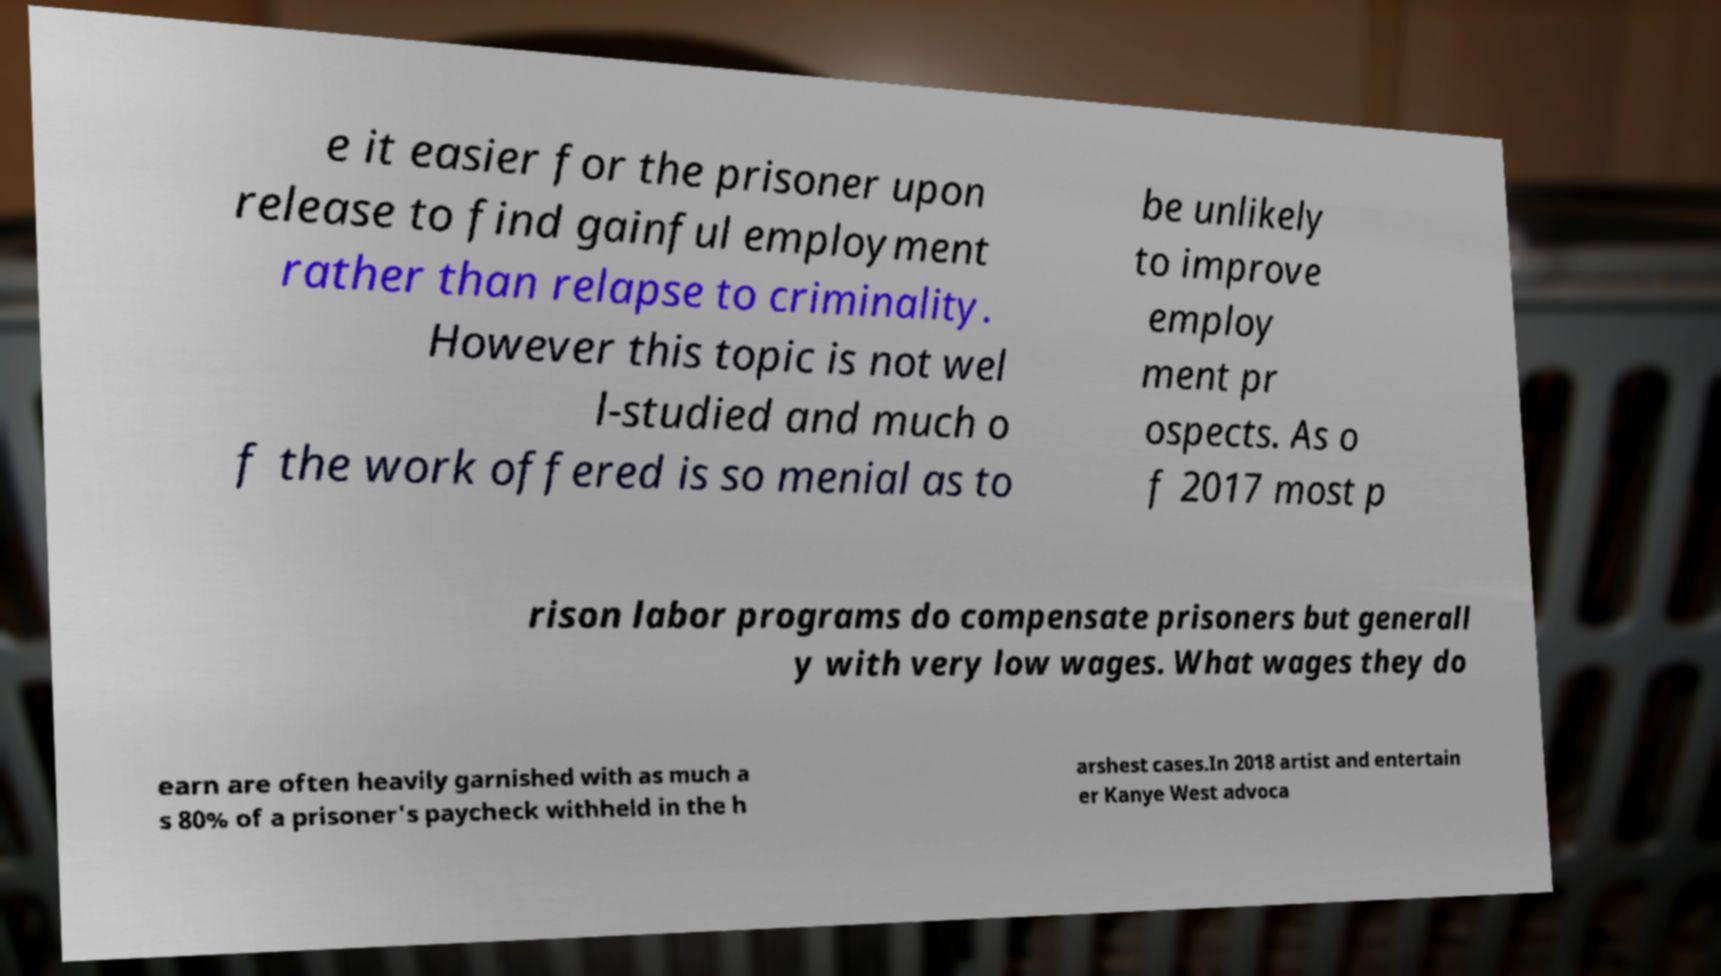There's text embedded in this image that I need extracted. Can you transcribe it verbatim? e it easier for the prisoner upon release to find gainful employment rather than relapse to criminality. However this topic is not wel l-studied and much o f the work offered is so menial as to be unlikely to improve employ ment pr ospects. As o f 2017 most p rison labor programs do compensate prisoners but generall y with very low wages. What wages they do earn are often heavily garnished with as much a s 80% of a prisoner's paycheck withheld in the h arshest cases.In 2018 artist and entertain er Kanye West advoca 